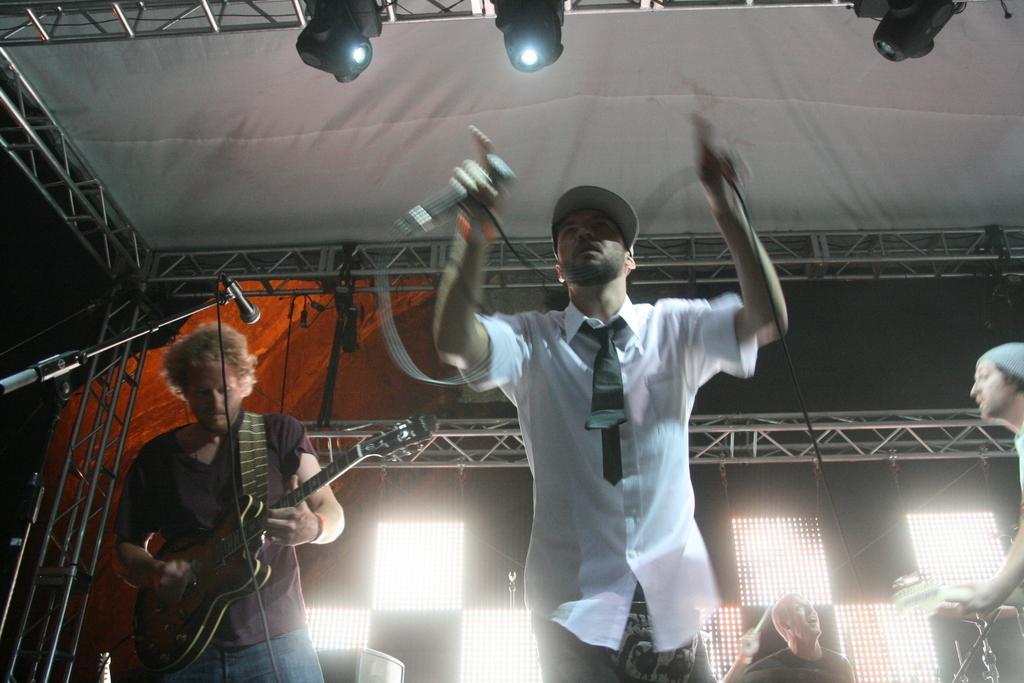Could you give a brief overview of what you see in this image? In the middle of the image a man is holding microphone. Bottom right side of the image a man is playing guitar. Bottom left side of the image a man is playing guitar. Bottom of the image a man is holding drumstick. Top of the image there is roof and lights. 